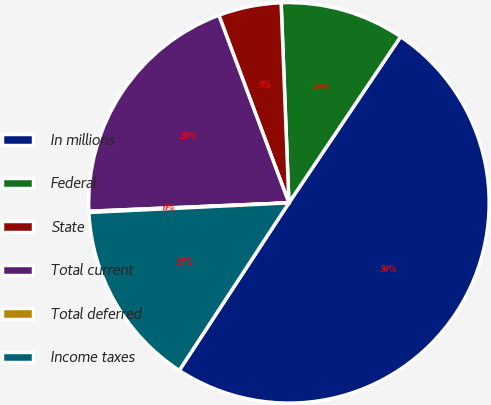Convert chart to OTSL. <chart><loc_0><loc_0><loc_500><loc_500><pie_chart><fcel>In millions<fcel>Federal<fcel>State<fcel>Total current<fcel>Total deferred<fcel>Income taxes<nl><fcel>49.8%<fcel>10.04%<fcel>5.07%<fcel>19.98%<fcel>0.1%<fcel>15.01%<nl></chart> 